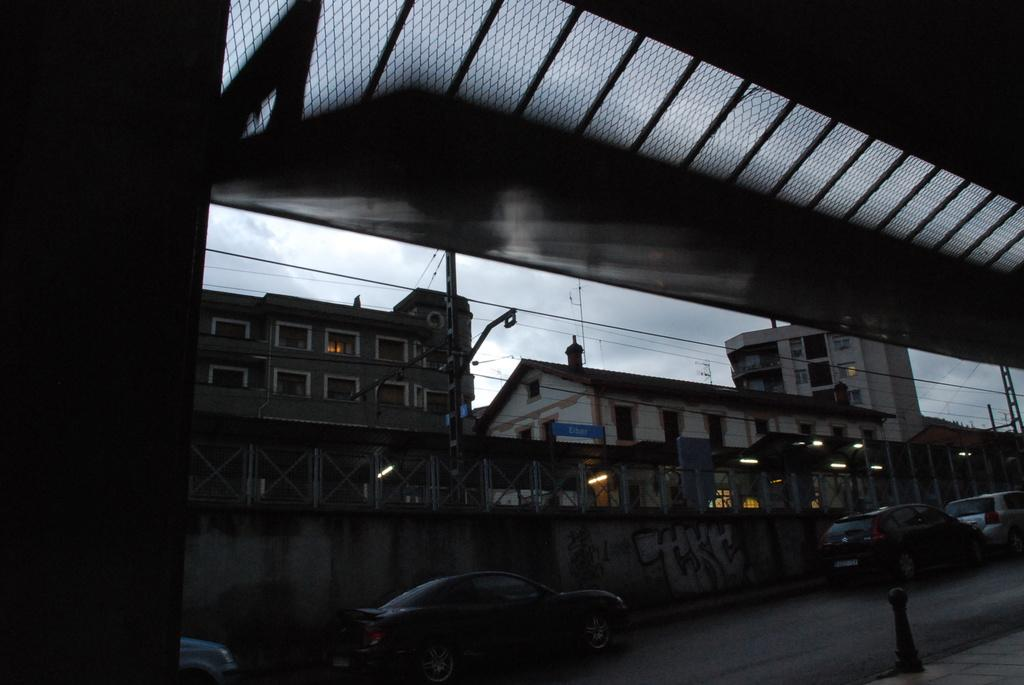What structure is the main subject of the image? There is a bridge in the image. What is happening near the bridge? Vehicles are visible on the road near the bridge. What can be seen in the background of the image? There is a fence, many buildings, lights, and the sky visible in the background of the image. What channel is the bridge featured on in the image? The image does not depict a television channel; it is a photograph or illustration of a bridge. 